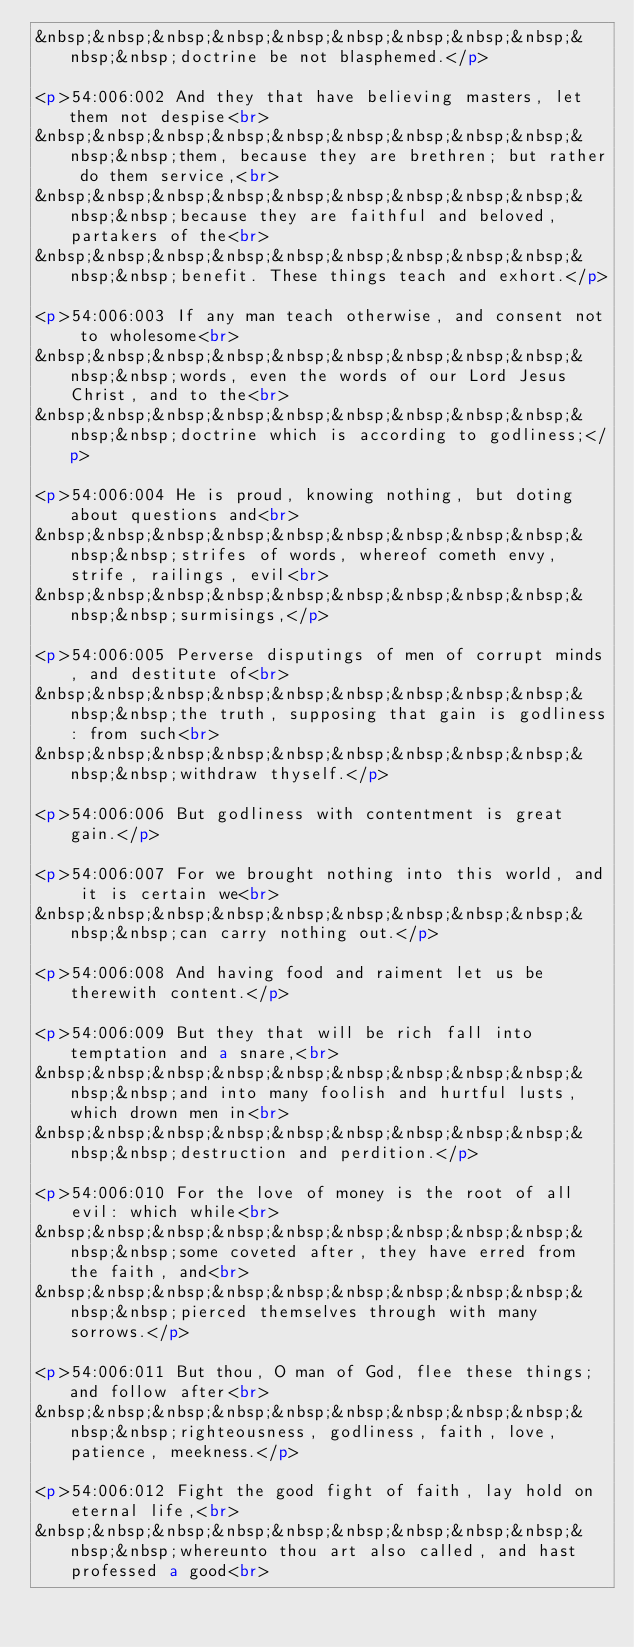<code> <loc_0><loc_0><loc_500><loc_500><_HTML_>&nbsp;&nbsp;&nbsp;&nbsp;&nbsp;&nbsp;&nbsp;&nbsp;&nbsp;&nbsp;&nbsp;doctrine be not blasphemed.</p>

<p>54:006:002 And they that have believing masters, let them not despise<br>
&nbsp;&nbsp;&nbsp;&nbsp;&nbsp;&nbsp;&nbsp;&nbsp;&nbsp;&nbsp;&nbsp;them, because they are brethren; but rather do them service,<br>
&nbsp;&nbsp;&nbsp;&nbsp;&nbsp;&nbsp;&nbsp;&nbsp;&nbsp;&nbsp;&nbsp;because they are faithful and beloved, partakers of the<br>
&nbsp;&nbsp;&nbsp;&nbsp;&nbsp;&nbsp;&nbsp;&nbsp;&nbsp;&nbsp;&nbsp;benefit. These things teach and exhort.</p>

<p>54:006:003 If any man teach otherwise, and consent not to wholesome<br>
&nbsp;&nbsp;&nbsp;&nbsp;&nbsp;&nbsp;&nbsp;&nbsp;&nbsp;&nbsp;&nbsp;words, even the words of our Lord Jesus Christ, and to the<br>
&nbsp;&nbsp;&nbsp;&nbsp;&nbsp;&nbsp;&nbsp;&nbsp;&nbsp;&nbsp;&nbsp;doctrine which is according to godliness;</p>

<p>54:006:004 He is proud, knowing nothing, but doting about questions and<br>
&nbsp;&nbsp;&nbsp;&nbsp;&nbsp;&nbsp;&nbsp;&nbsp;&nbsp;&nbsp;&nbsp;strifes of words, whereof cometh envy, strife, railings, evil<br>
&nbsp;&nbsp;&nbsp;&nbsp;&nbsp;&nbsp;&nbsp;&nbsp;&nbsp;&nbsp;&nbsp;surmisings,</p>

<p>54:006:005 Perverse disputings of men of corrupt minds, and destitute of<br>
&nbsp;&nbsp;&nbsp;&nbsp;&nbsp;&nbsp;&nbsp;&nbsp;&nbsp;&nbsp;&nbsp;the truth, supposing that gain is godliness: from such<br>
&nbsp;&nbsp;&nbsp;&nbsp;&nbsp;&nbsp;&nbsp;&nbsp;&nbsp;&nbsp;&nbsp;withdraw thyself.</p>

<p>54:006:006 But godliness with contentment is great gain.</p>

<p>54:006:007 For we brought nothing into this world, and it is certain we<br>
&nbsp;&nbsp;&nbsp;&nbsp;&nbsp;&nbsp;&nbsp;&nbsp;&nbsp;&nbsp;&nbsp;can carry nothing out.</p>

<p>54:006:008 And having food and raiment let us be therewith content.</p>

<p>54:006:009 But they that will be rich fall into temptation and a snare,<br>
&nbsp;&nbsp;&nbsp;&nbsp;&nbsp;&nbsp;&nbsp;&nbsp;&nbsp;&nbsp;&nbsp;and into many foolish and hurtful lusts, which drown men in<br>
&nbsp;&nbsp;&nbsp;&nbsp;&nbsp;&nbsp;&nbsp;&nbsp;&nbsp;&nbsp;&nbsp;destruction and perdition.</p>

<p>54:006:010 For the love of money is the root of all evil: which while<br>
&nbsp;&nbsp;&nbsp;&nbsp;&nbsp;&nbsp;&nbsp;&nbsp;&nbsp;&nbsp;&nbsp;some coveted after, they have erred from the faith, and<br>
&nbsp;&nbsp;&nbsp;&nbsp;&nbsp;&nbsp;&nbsp;&nbsp;&nbsp;&nbsp;&nbsp;pierced themselves through with many sorrows.</p>

<p>54:006:011 But thou, O man of God, flee these things; and follow after<br>
&nbsp;&nbsp;&nbsp;&nbsp;&nbsp;&nbsp;&nbsp;&nbsp;&nbsp;&nbsp;&nbsp;righteousness, godliness, faith, love, patience, meekness.</p>

<p>54:006:012 Fight the good fight of faith, lay hold on eternal life,<br>
&nbsp;&nbsp;&nbsp;&nbsp;&nbsp;&nbsp;&nbsp;&nbsp;&nbsp;&nbsp;&nbsp;whereunto thou art also called, and hast professed a good<br></code> 